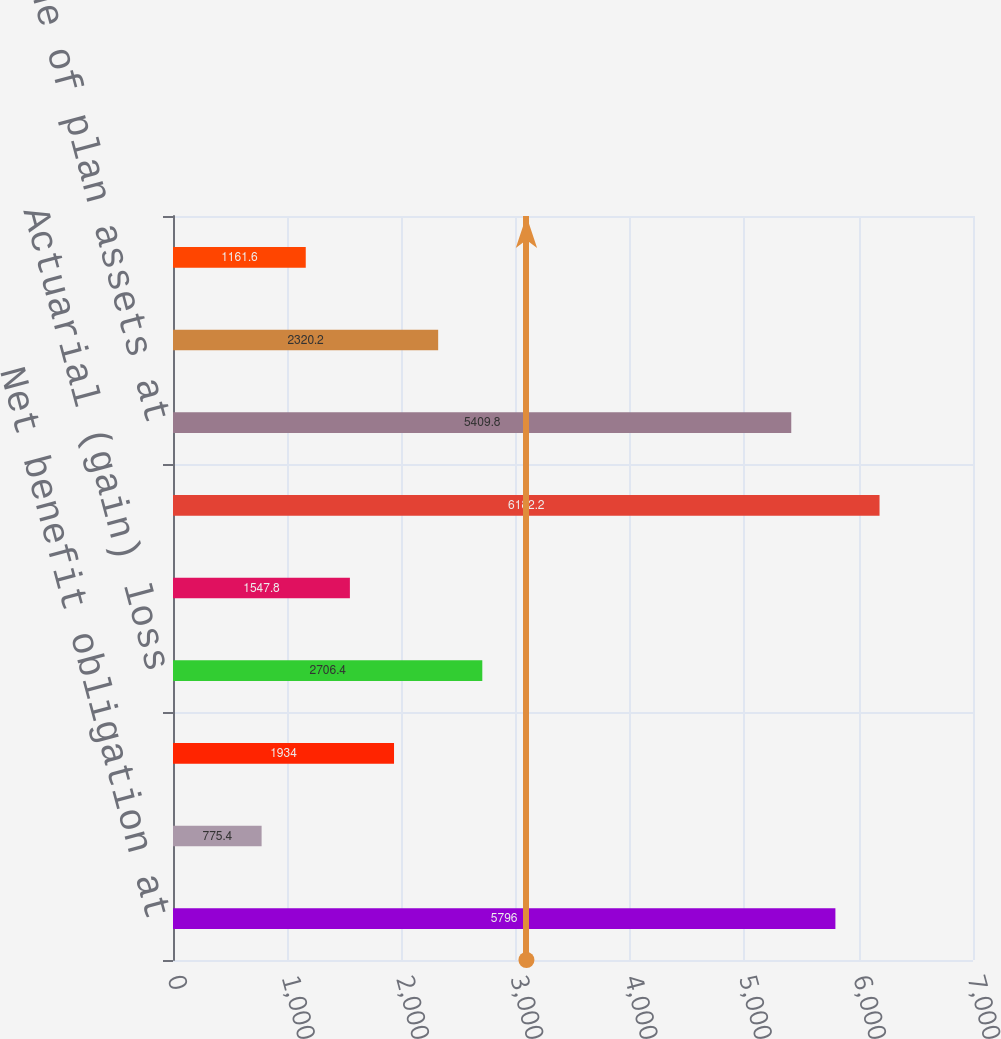<chart> <loc_0><loc_0><loc_500><loc_500><bar_chart><fcel>Net benefit obligation at<fcel>Service cost<fcel>Interest cost<fcel>Actuarial (gain) loss<fcel>Benefits paid<fcel>Net benefit obligation at end<fcel>Fair value of plan assets at<fcel>Actual return on plan assets<fcel>Employer contributions<nl><fcel>5796<fcel>775.4<fcel>1934<fcel>2706.4<fcel>1547.8<fcel>6182.2<fcel>5409.8<fcel>2320.2<fcel>1161.6<nl></chart> 